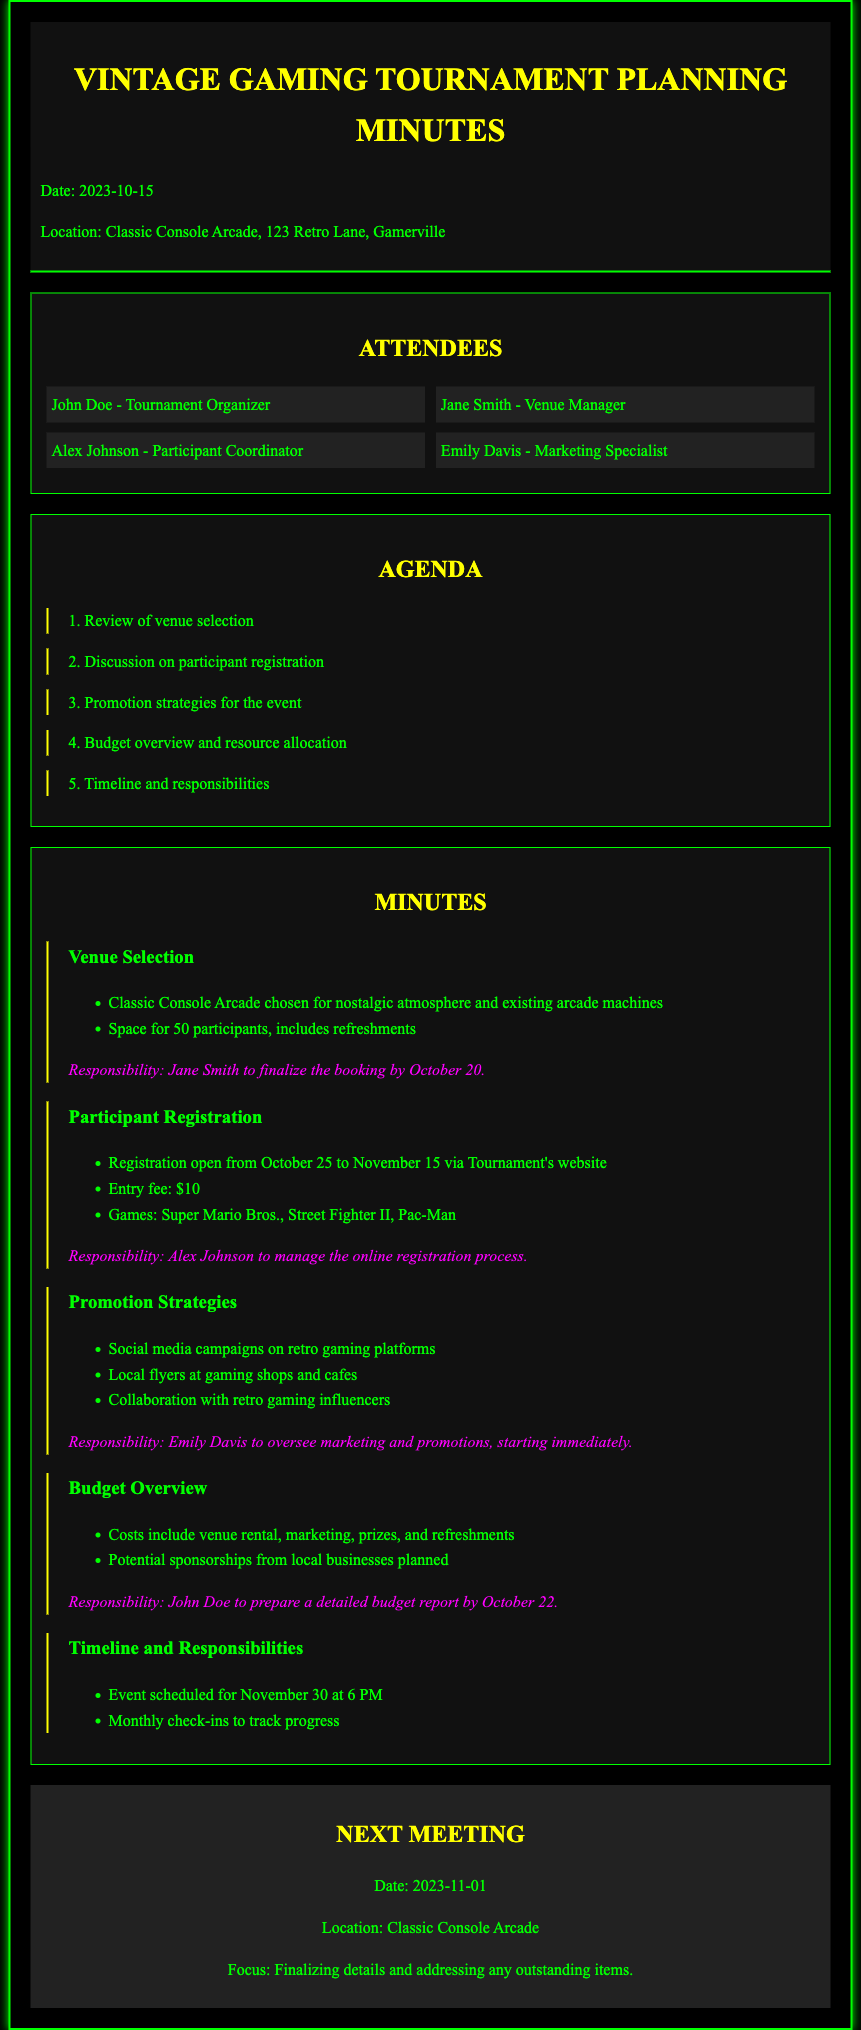What is the date of the meeting? The document states the date of the meeting as October 15, 2023.
Answer: October 15, 2023 Where is the tournament being held? The location mentioned in the document for the tournament is Classic Console Arcade, 123 Retro Lane, Gamerville.
Answer: Classic Console Arcade Who is responsible for finalizing the venue booking? The responsibility for finalizing the booking is assigned to Jane Smith.
Answer: Jane Smith What is the entry fee for participants? The document specifies that the entry fee for participants is $10.
Answer: $10 When does participant registration open? The registration opening date as per the document is October 25, 2023.
Answer: October 25 How many participants can the venue accommodate? The document states that the venue can accommodate 50 participants.
Answer: 50 participants What is the date and time of the event? The event is scheduled for November 30 at 6 PM according to the document.
Answer: November 30 at 6 PM Which games are included in the tournament? The games listed for inclusion in the tournament are Super Mario Bros., Street Fighter II, and Pac-Man.
Answer: Super Mario Bros., Street Fighter II, Pac-Man What topic will the next meeting focus on? The focus of the next meeting, as stated in the document, is finalizing details and addressing any outstanding items.
Answer: Finalizing details and addressing any outstanding items 